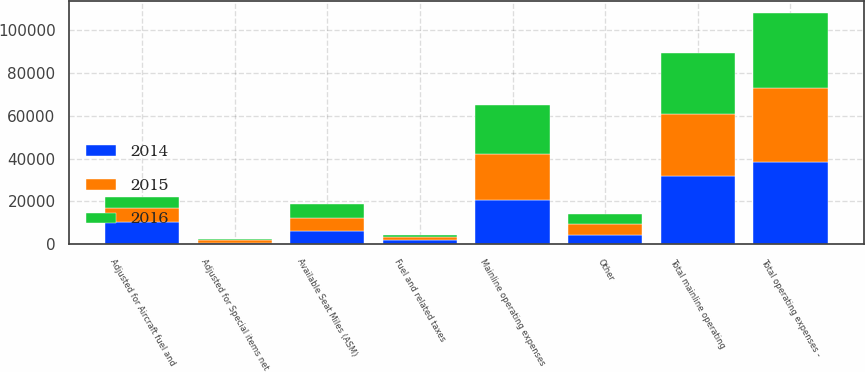Convert chart to OTSL. <chart><loc_0><loc_0><loc_500><loc_500><stacked_bar_chart><ecel><fcel>Total operating expenses -<fcel>Fuel and related taxes<fcel>Other<fcel>Total mainline operating<fcel>Adjusted for Special items net<fcel>Adjusted for Aircraft fuel and<fcel>Mainline operating expenses<fcel>Available Seat Miles (ASM)<nl><fcel>2016<fcel>34896<fcel>1109<fcel>4935<fcel>28852<fcel>709<fcel>5071<fcel>23072<fcel>6226<nl><fcel>2015<fcel>34786<fcel>1230<fcel>4753<fcel>28803<fcel>1051<fcel>6226<fcel>21526<fcel>6226<nl><fcel>2014<fcel>38401<fcel>2009<fcel>4507<fcel>31885<fcel>800<fcel>10592<fcel>20493<fcel>6226<nl></chart> 